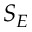Convert formula to latex. <formula><loc_0><loc_0><loc_500><loc_500>S _ { E }</formula> 